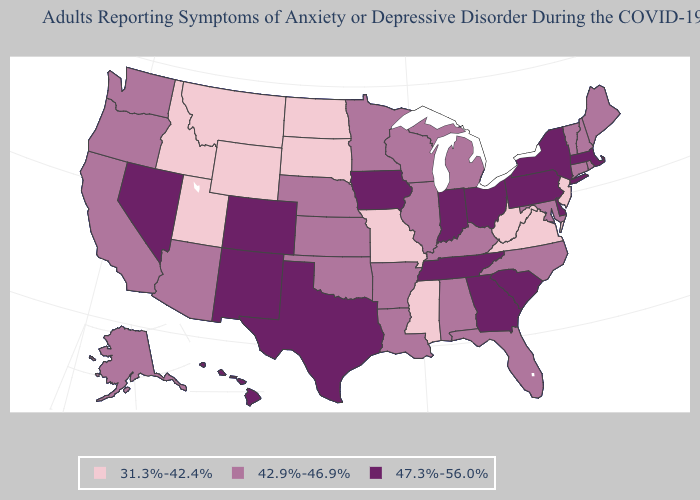What is the highest value in states that border Connecticut?
Concise answer only. 47.3%-56.0%. What is the highest value in the USA?
Answer briefly. 47.3%-56.0%. Does South Carolina have the highest value in the USA?
Quick response, please. Yes. Name the states that have a value in the range 31.3%-42.4%?
Be succinct. Idaho, Mississippi, Missouri, Montana, New Jersey, North Dakota, South Dakota, Utah, Virginia, West Virginia, Wyoming. What is the value of Ohio?
Short answer required. 47.3%-56.0%. Which states have the lowest value in the USA?
Write a very short answer. Idaho, Mississippi, Missouri, Montana, New Jersey, North Dakota, South Dakota, Utah, Virginia, West Virginia, Wyoming. Name the states that have a value in the range 42.9%-46.9%?
Write a very short answer. Alabama, Alaska, Arizona, Arkansas, California, Connecticut, Florida, Illinois, Kansas, Kentucky, Louisiana, Maine, Maryland, Michigan, Minnesota, Nebraska, New Hampshire, North Carolina, Oklahoma, Oregon, Rhode Island, Vermont, Washington, Wisconsin. What is the highest value in the USA?
Write a very short answer. 47.3%-56.0%. Does Kentucky have a higher value than Idaho?
Answer briefly. Yes. Does Ohio have the highest value in the MidWest?
Concise answer only. Yes. What is the value of Wisconsin?
Keep it brief. 42.9%-46.9%. Does the map have missing data?
Write a very short answer. No. Name the states that have a value in the range 31.3%-42.4%?
Keep it brief. Idaho, Mississippi, Missouri, Montana, New Jersey, North Dakota, South Dakota, Utah, Virginia, West Virginia, Wyoming. Does the first symbol in the legend represent the smallest category?
Quick response, please. Yes. Name the states that have a value in the range 47.3%-56.0%?
Keep it brief. Colorado, Delaware, Georgia, Hawaii, Indiana, Iowa, Massachusetts, Nevada, New Mexico, New York, Ohio, Pennsylvania, South Carolina, Tennessee, Texas. 